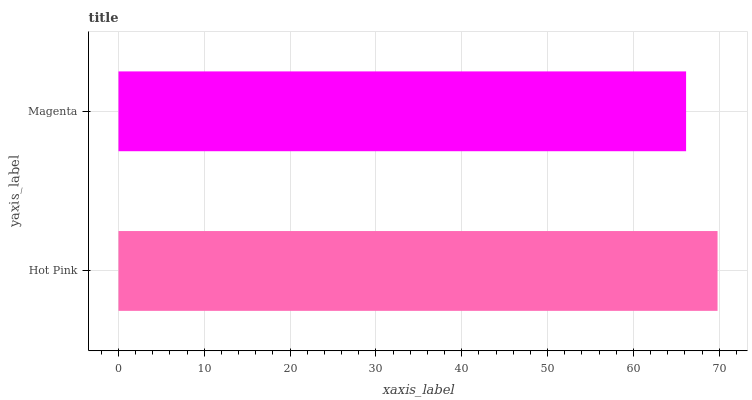Is Magenta the minimum?
Answer yes or no. Yes. Is Hot Pink the maximum?
Answer yes or no. Yes. Is Magenta the maximum?
Answer yes or no. No. Is Hot Pink greater than Magenta?
Answer yes or no. Yes. Is Magenta less than Hot Pink?
Answer yes or no. Yes. Is Magenta greater than Hot Pink?
Answer yes or no. No. Is Hot Pink less than Magenta?
Answer yes or no. No. Is Hot Pink the high median?
Answer yes or no. Yes. Is Magenta the low median?
Answer yes or no. Yes. Is Magenta the high median?
Answer yes or no. No. Is Hot Pink the low median?
Answer yes or no. No. 